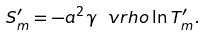<formula> <loc_0><loc_0><loc_500><loc_500>S ^ { \prime } _ { m } = - { a ^ { 2 } \gamma \ v r h o } \ln T _ { m } ^ { \prime } .</formula> 